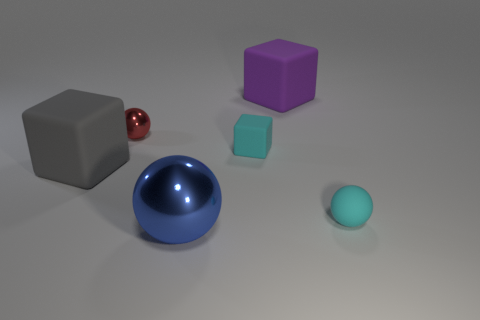Add 2 gray rubber cubes. How many objects exist? 8 Subtract 1 cyan blocks. How many objects are left? 5 Subtract all rubber blocks. Subtract all small matte balls. How many objects are left? 2 Add 6 big things. How many big things are left? 9 Add 1 blocks. How many blocks exist? 4 